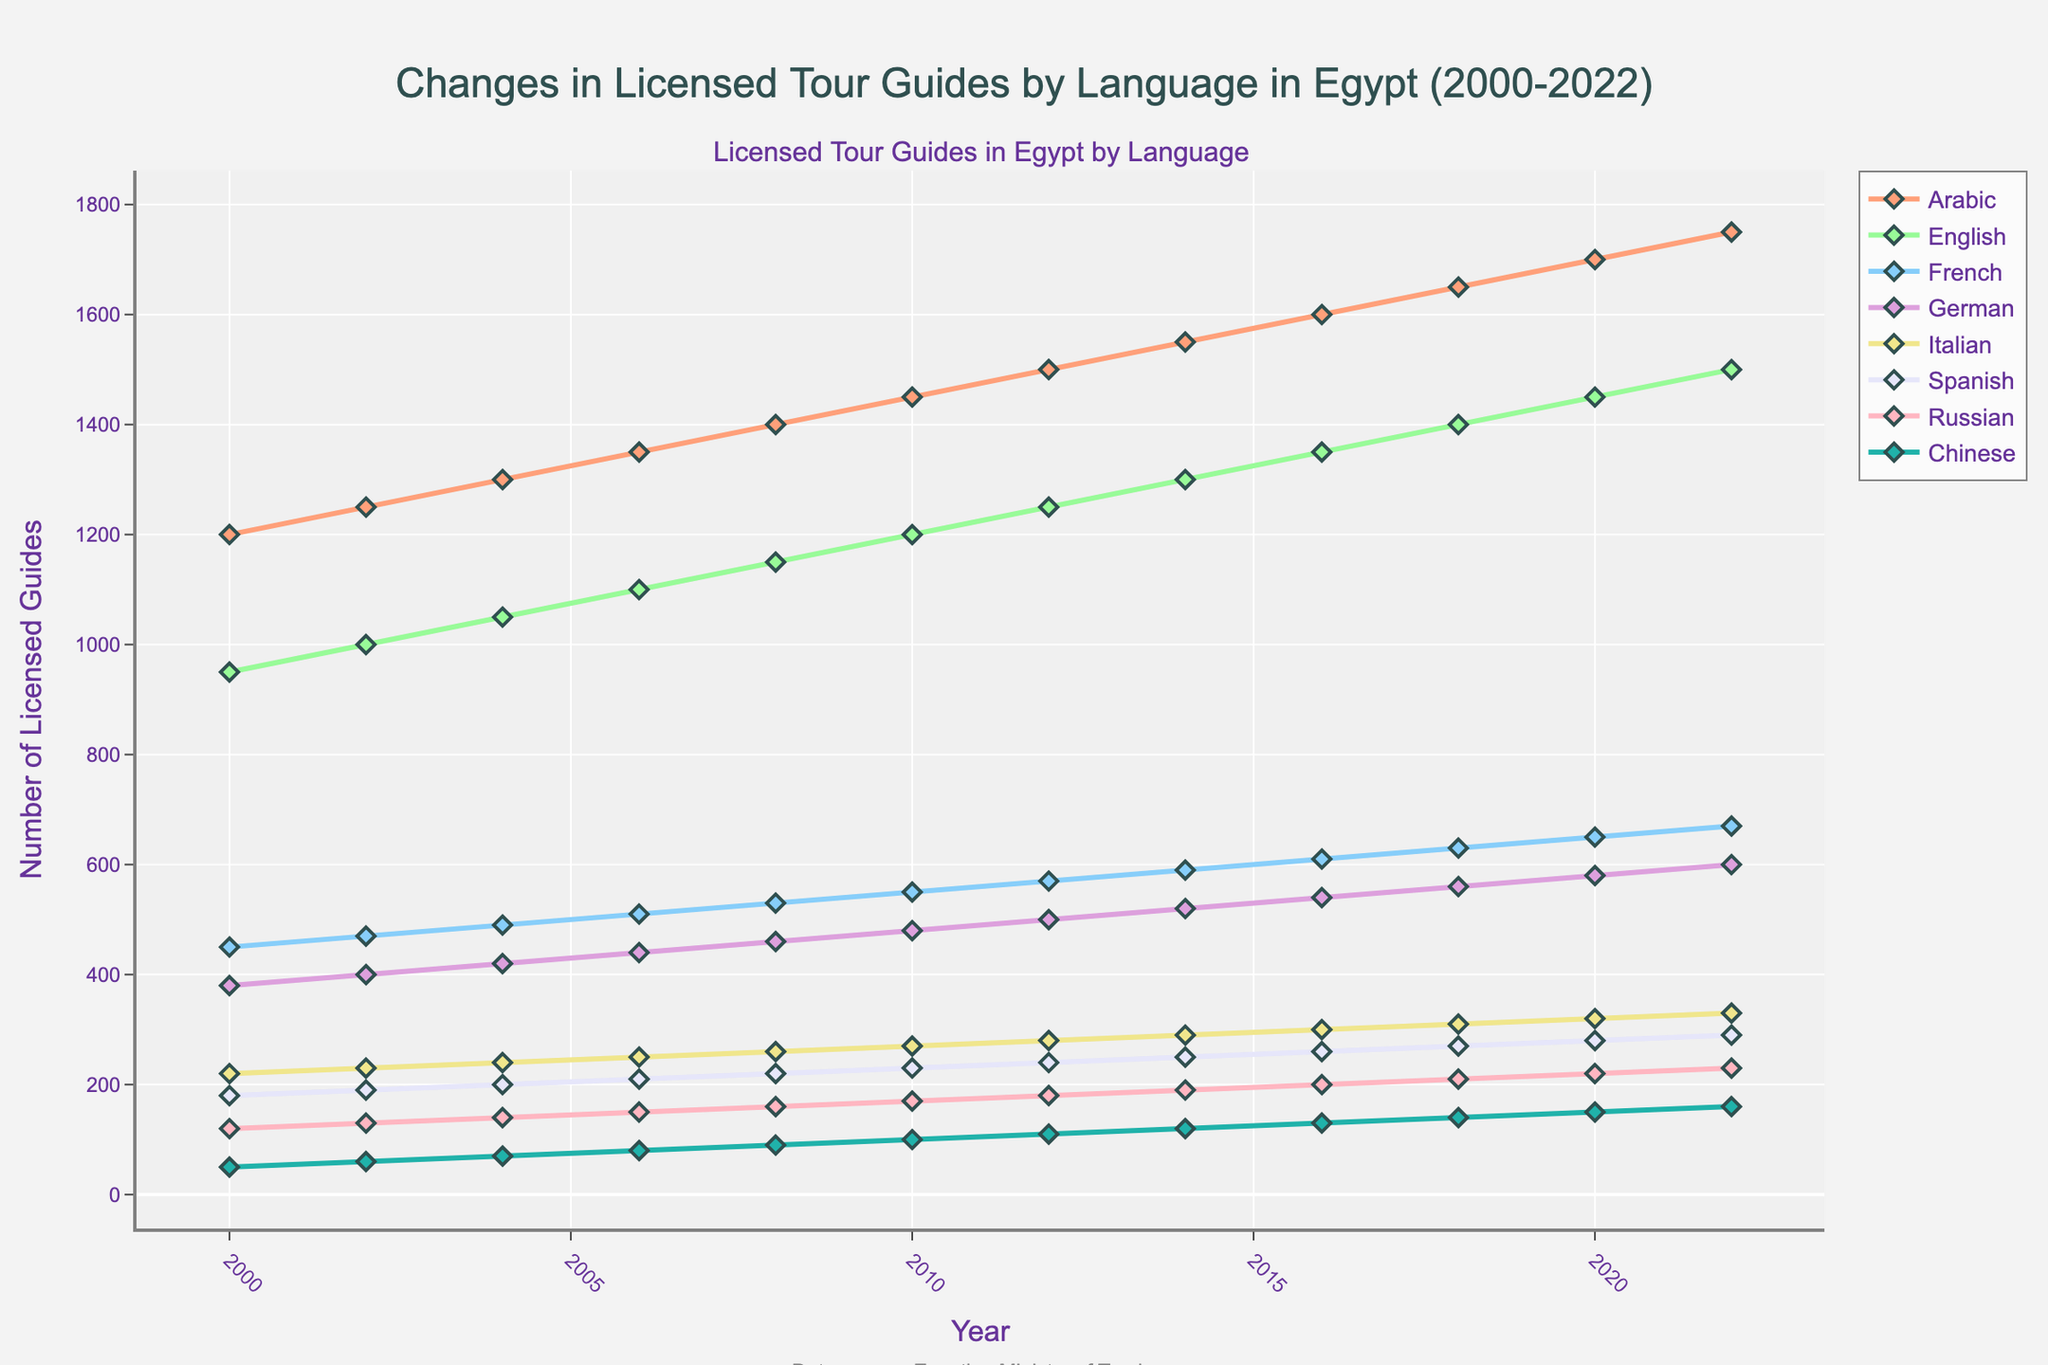What language specialization experienced the highest increase in the number of licensed tour guides from 2000 to 2022? To determine the language specialization with the highest increase, subtract the number of licensed guides in 2000 from the number in 2022 for each language, and then compare the differences. For Arabic: 1750 - 1200 = 550, for English: 1500 - 950 = 550, and so on. Arabic and English both increased by 550, which is the highest among all.
Answer: Arabic, English Which year marked the first instance where the number of licensed Spanish-speaking tour guides reached or exceeded 200? To find the first instance where Spanish-speaking tour guides reached 200, check the year-wise data for Spanish. In 2008, the number of Spanish-speaking guides was 220.
Answer: 2008 In 2016, how did the number of licensed Chinese-speaking tour guides compare with Italian-speaking tour guides? For 2016, check the numbers for both Chinese and Italian-speaking guides. Chinese: 130, Italian: 300. Compare the two numbers.
Answer: Italian-speaking guides were more What is the average number of licensed French-speaking tour guides from 2000 to 2022? To find the average, sum the number of French-speaking guides from 2000 to 2022 and divide by the number of data points (12). Sum: 450 + 470 + 490 + 510 + 530 + 550 + 570 + 590 + 610 + 630 + 650 + 670 = 6720. Average: 6720 / 12 = 560.
Answer: 560 Which language specialization maintained a consistent increment in the number of licensed tour guides every year? Check the increments in the number of licensed guides year by year for consistency. Arabic consistently increases by 50 guides each period.
Answer: Arabic In which year did the number of licensed German-speaking tour guides first exceed 500? By checking the data year-wise, in 2012, the number of licensed German-speaking guides is 500, but it first exceeds 500 in 2014 with 520 German-speaking guides.
Answer: 2014 Between 2000 and 2022, which language had the least number of licensed tour guides in 2022, and what was that number? Compare the number of licensed guides for each language in 2022. The least number in 2022 was for Chinese-speaking guides, which was 160.
Answer: Chinese, 160 What is the total number of licensed English-speaking tour guides from 2000 to 2022? Sum the number of English-speaking guides for each year from 2000 to 2022. Sum: 950 + 1000 + 1050 + 1100 + 1150 + 1200 + 1250 + 1300 + 1350 + 1400 + 1450 + 1500 = 14400.
Answer: 14400 Compare the growth patterns of Arabic and Russian-speaking tour guides between 2000 and 2022. Which had a more considerable absolute increase, and by how much? Calculate the absolute increase for both languages: Arabic: 1750 - 1200 = 550, Russian: 230 - 120 = 110. Compare the increases: 550 - 110 = 440. Arabic had a larger increase by 440.
Answer: Arabic, 440 How many more Italian-speaking tour guides were there than Spanish-speaking tour guides in 2022? For 2022, subtract the number of Spanish-speaking guides from Italian-speaking guides. Italian: 330, Spanish: 290. Difference: 330 - 290 = 40.
Answer: 40 